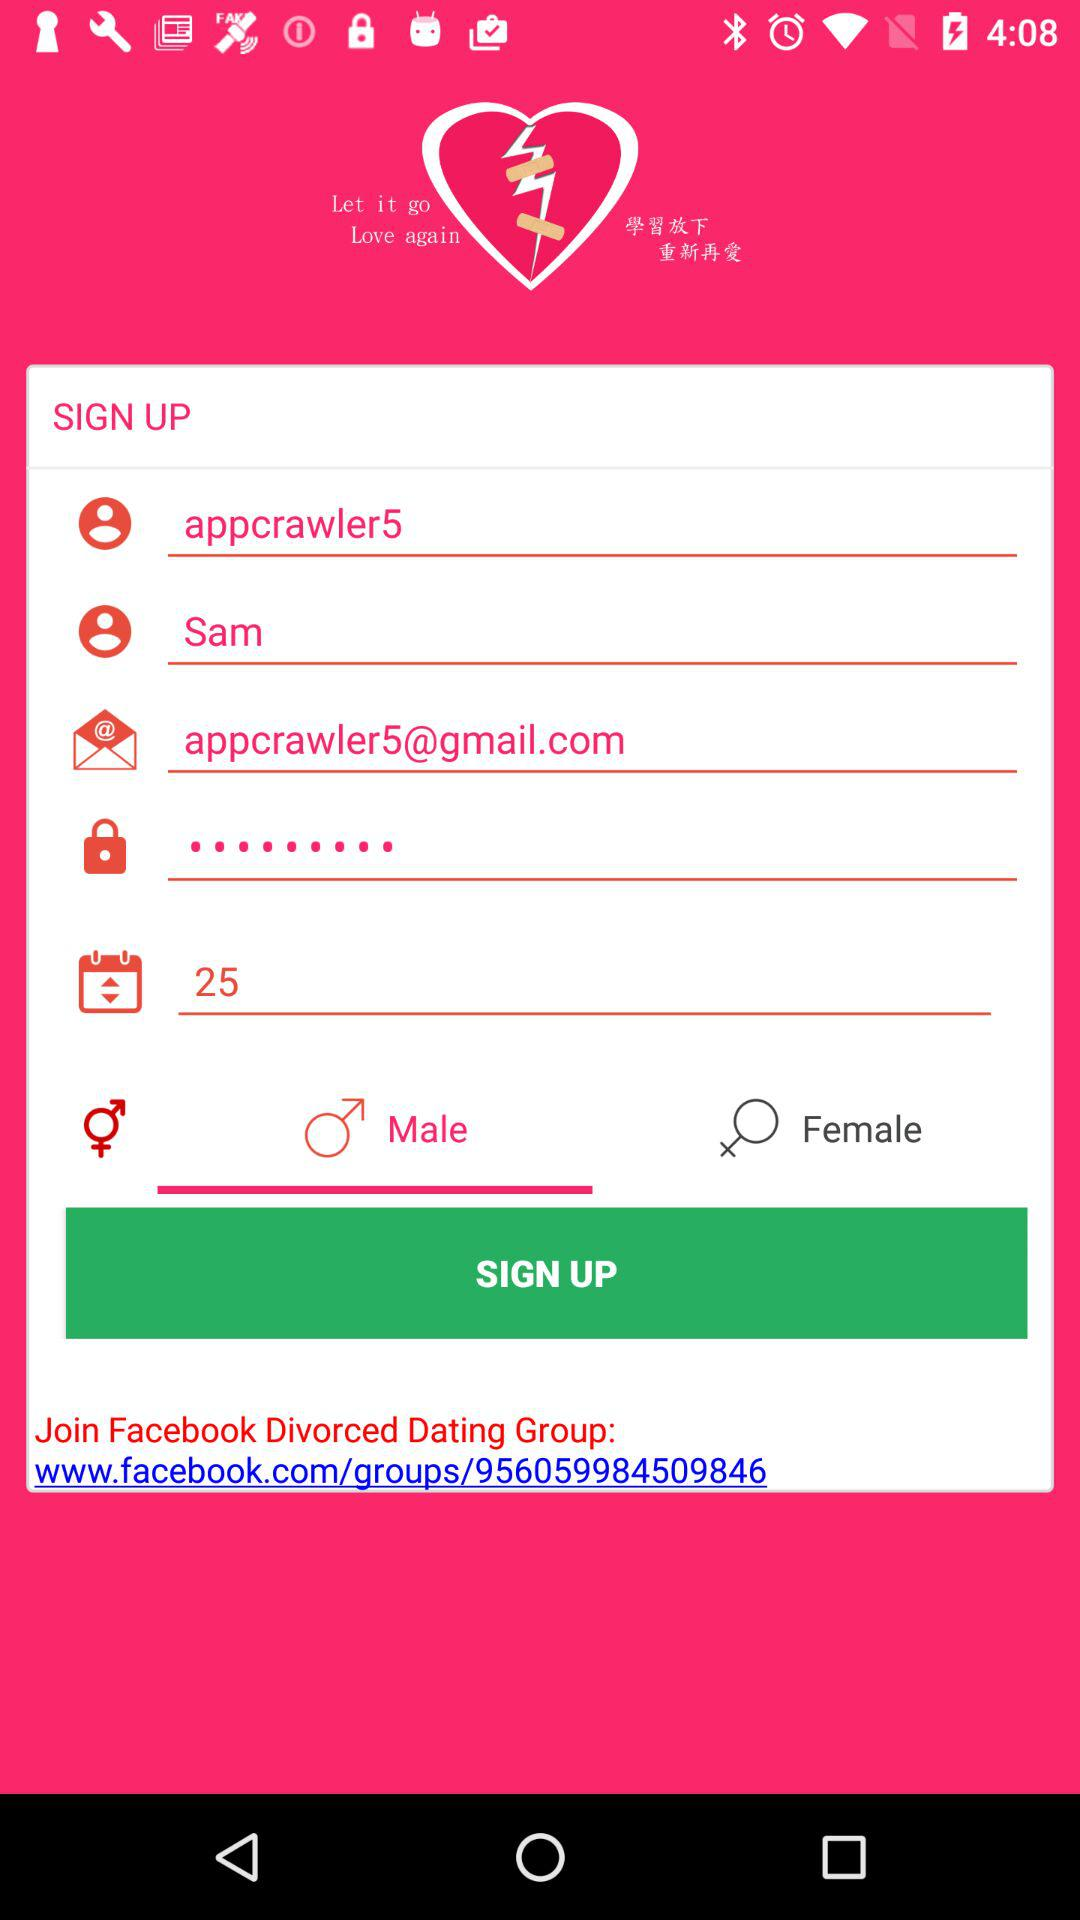What is the username? The username is appcrawler5. 